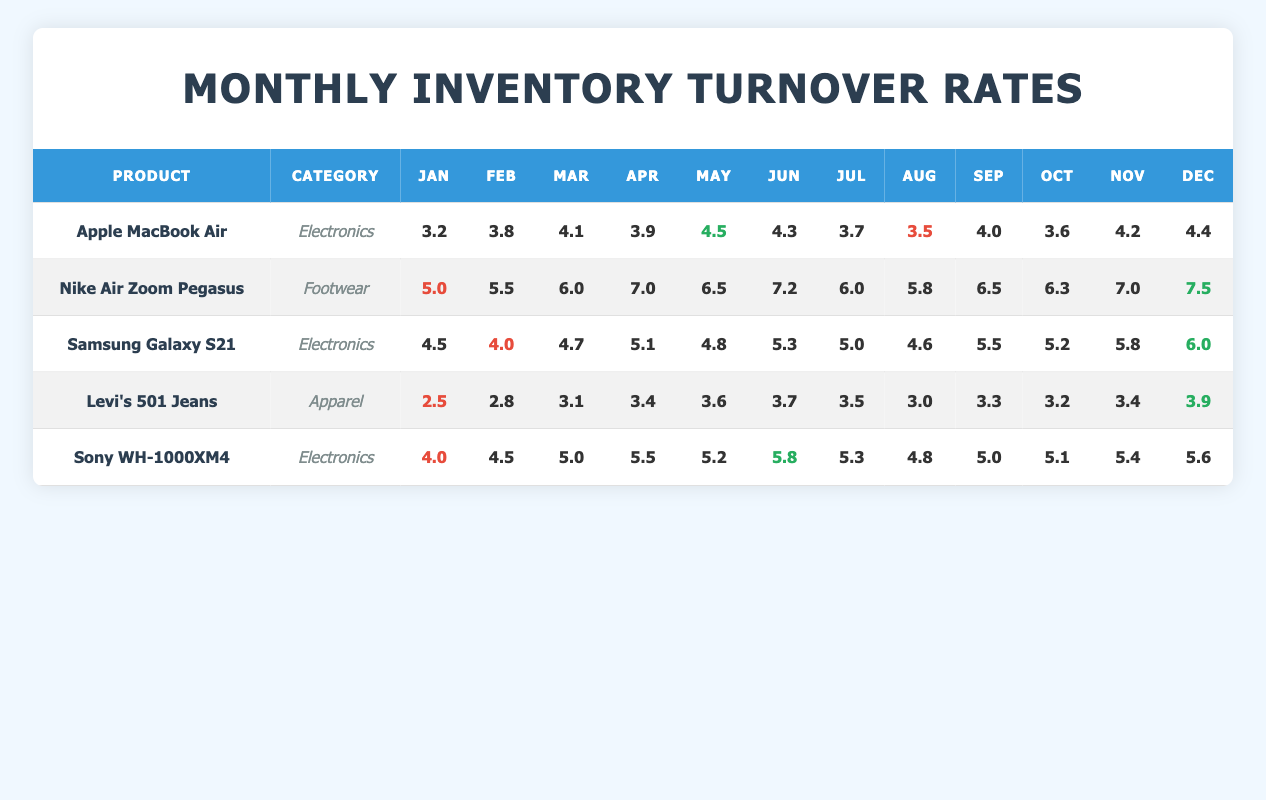What is the highest monthly inventory turnover rate for the Apple MacBook Air? The highest monthly turnover rate for the Apple MacBook Air is found by looking at the monthly turnover values from January to December. Upon inspection, the highest value is 4.5, which occurs in May.
Answer: 4.5 In which month did the Nike Air Zoom Pegasus have the lowest turnover rate? By examining the monthly turnover rates for the Nike Air Zoom Pegasus, January shows the lowest turnover rate of 5.0 compared to the other months.
Answer: January What was the average turnover rate for the Samsung Galaxy S21 over the year? To find the average turnover for the Samsung Galaxy S21, we sum all monthly turnover rates: 4.5 + 4.0 + 4.7 + 5.1 + 4.8 + 5.3 + 5.0 + 4.6 + 5.5 + 5.2 + 5.8 + 6.0 = 61.5, and divide by 12 months. Thus, the average is 61.5/12 = 5.125.
Answer: 5.125 Did the Levi's 501 Jeans ever exceed a monthly turnover rate of 4.0? Reviewing the monthly turnover rates for Levi's 501 Jeans, we see that the highest value is 3.9 in December, which does not exceed 4.0. Thus, the answer is no.
Answer: No Which product had the most consistent turnover rates, based on the smallest difference between its highest and lowest monthly rate? By evaluating the monthly turnover rates for each product, Levi's 501 Jeans has the smallest difference between its highest (3.9) and lowest (2.5) turnover rates, resulting in a difference of 1.4. In comparison, other products exhibit larger differences.
Answer: Levi's 501 Jeans What is the total turnover rate increase for the Nike Air Zoom Pegasus from January to December? To determine the total turnover rate increase for Nike Air Zoom Pegasus, subtract the January rate (5.0) from the December rate (7.5). Therefore: 7.5 - 5.0 = 2.5.
Answer: 2.5 In which category does the product with the smallest annual turnover rate belong? The product with the smallest annual turnover rate is Levi's 501 Jeans (annual turnover of 3.4). Checking the product's category, it belongs to Apparel.
Answer: Apparel What was the turnover rate for Sony WH-1000XM4 in June? Looking at the monthly turnover for Sony WH-1000XM4, the turnover rate in June is 5.8.
Answer: 5.8 